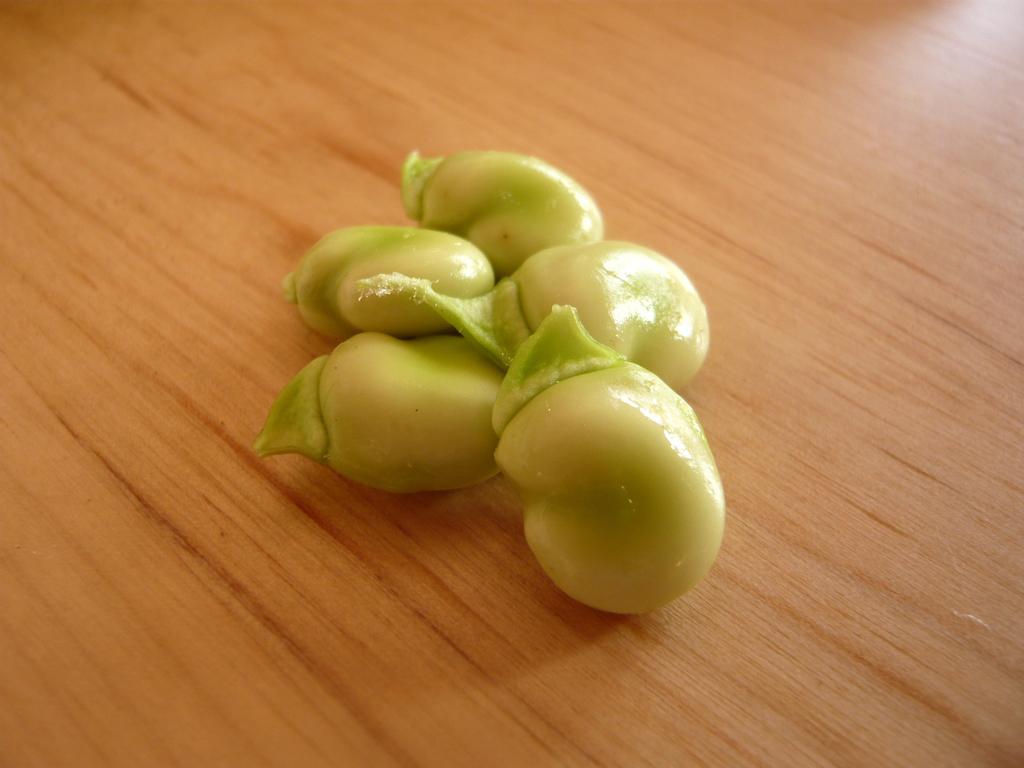Please provide a concise description of this image. These are the broad beans, which are light green in color. These beans are placed on the wooden table. 